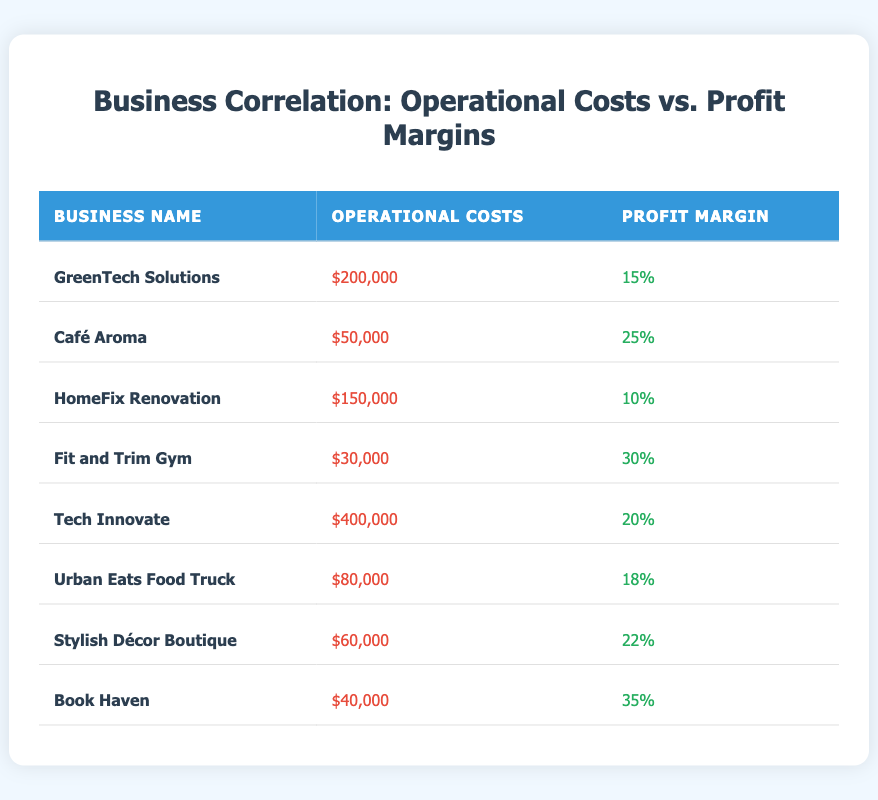What is the profit margin for Café Aroma? The profit margin for Café Aroma is shown in the table next to its operational costs and business name, which states that it is 25 percent.
Answer: 25 Which business has the highest operational costs? By scanning the operational costs column, Tech Innovate has the highest value at 400,000.
Answer: 400,000 What is the average profit margin of all businesses listed? To find the average profit margin, add all profit margins: 15 + 25 + 10 + 30 + 20 + 18 + 22 + 35 = 175. There are 8 businesses, so the average is 175 / 8 = 21.875, rounded to two decimal places gives 21.88.
Answer: 21.88 Is it true that Urban Eats Food Truck has a higher profit margin than HomeFix Renovation? Comparing the profit margins of both businesses, Urban Eats Food Truck has 18 while HomeFix Renovation has 10, thus the statement is true.
Answer: Yes What is the difference in operational costs between Fit and Trim Gym and Stylish Décor Boutique? Fit and Trim Gym has operational costs of 30,000, and Stylish Décor Boutique has 60,000. The difference is calculated by subtracting: 60,000 - 30,000 = 30,000.
Answer: 30,000 Which business has the lowest profit margin, and what is that margin? By reviewing the profit margin column, it is evident that HomeFix Renovation has the lowest profit margin listed at 10 percent.
Answer: HomeFix Renovation, 10 How many businesses have operational costs of over 100,000? By examining the operational costs, GreenTech Solutions (200,000) and Tech Innovate (400,000) are the only two businesses exceeding 100,000, resulting in a total of 2 businesses.
Answer: 2 What is the total operational costs of all the businesses combined? The total operational costs can be computed by adding up each business's operational cost: 200,000 + 50,000 + 150,000 + 30,000 + 400,000 + 80,000 + 60,000 + 40,000 = 1,010,000.
Answer: 1,010,000 Which business has the highest profit margin, and what is that margin? Looking at the profit margin column, Book Haven has the highest margin at 35 percent, making it the business with the best profit margin.
Answer: Book Haven, 35 